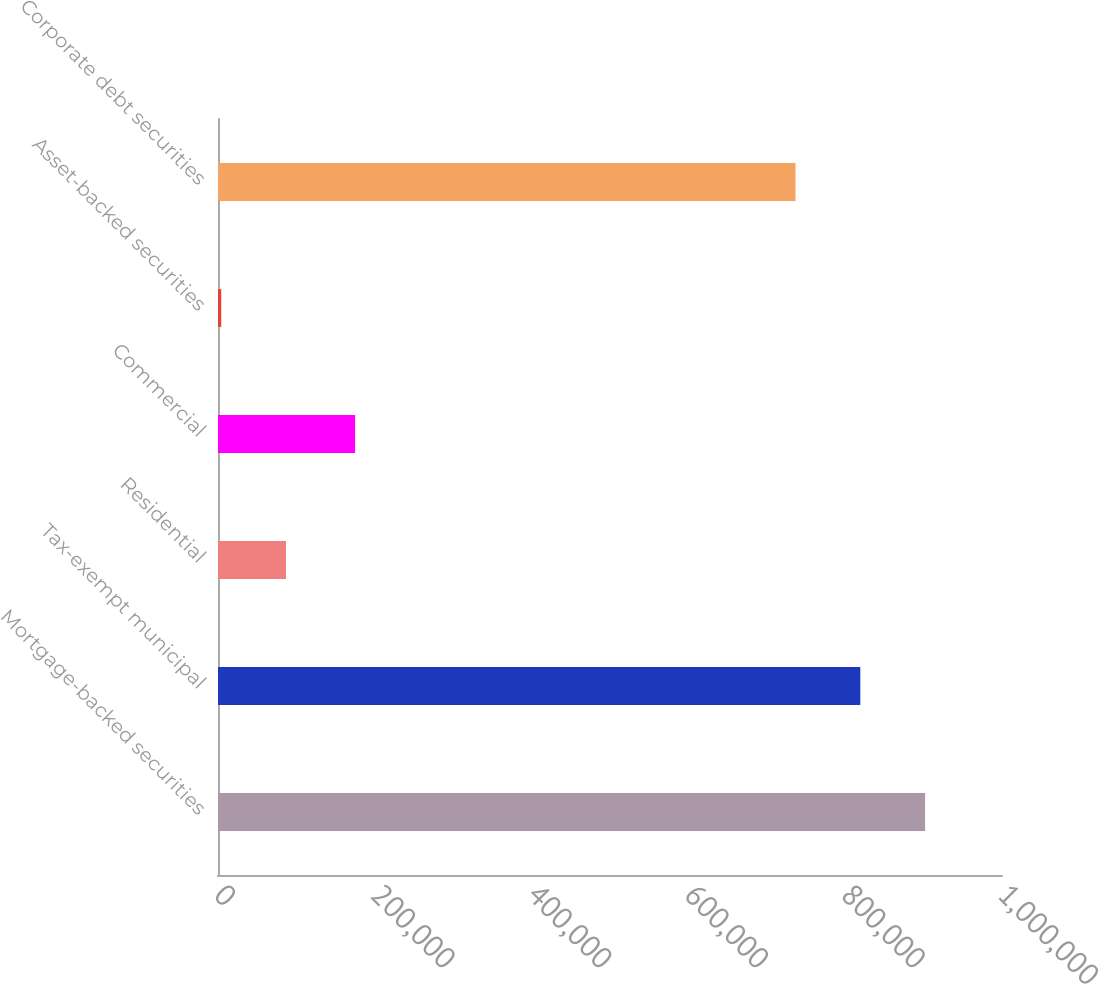Convert chart. <chart><loc_0><loc_0><loc_500><loc_500><bar_chart><fcel>Mortgage-backed securities<fcel>Tax-exempt municipal<fcel>Residential<fcel>Commercial<fcel>Asset-backed securities<fcel>Corporate debt securities<nl><fcel>901881<fcel>819272<fcel>86718<fcel>174885<fcel>4109<fcel>736663<nl></chart> 